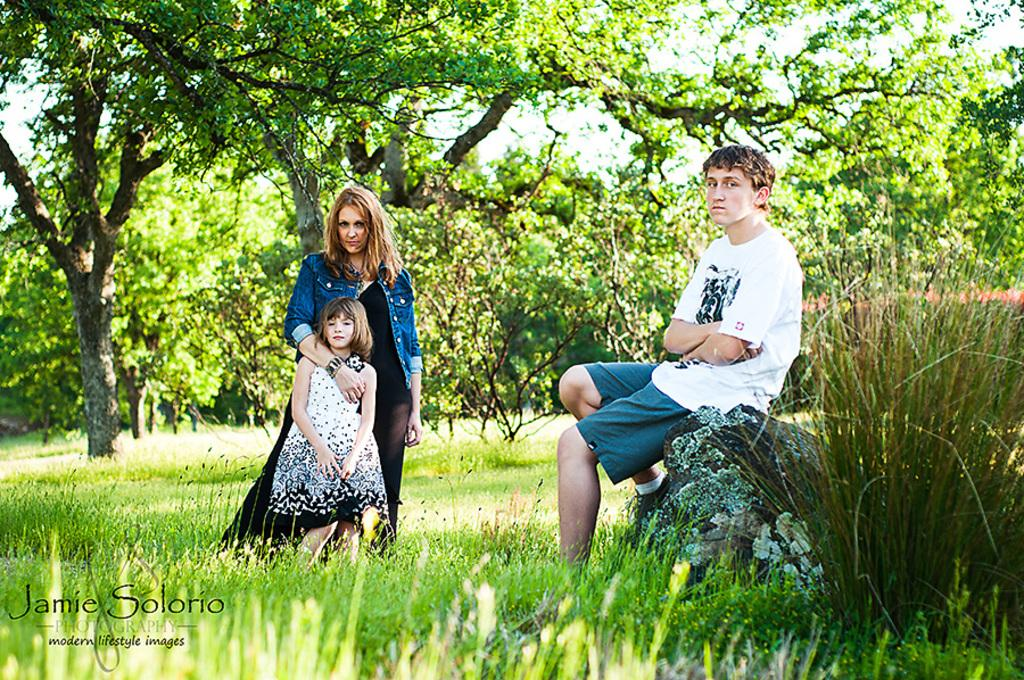What is the main subject of the image? The main subject of the image is a group of people. How can you describe the clothing of the people in the image? The people are wearing different color dresses. What type of natural environment is visible in the image? There is grass visible in the image, and there are many trees in the background. What is visible in the sky in the image? The sky is visible in the background of the image. What type of stitch is being used to sew the snow in the image? There is no snow or stitching present in the image. Can you tell me the name of the brother of one of the people in the image? There is no information about the people's siblings in the image. 